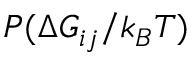<formula> <loc_0><loc_0><loc_500><loc_500>P ( \Delta G _ { i j } / k _ { B } T )</formula> 